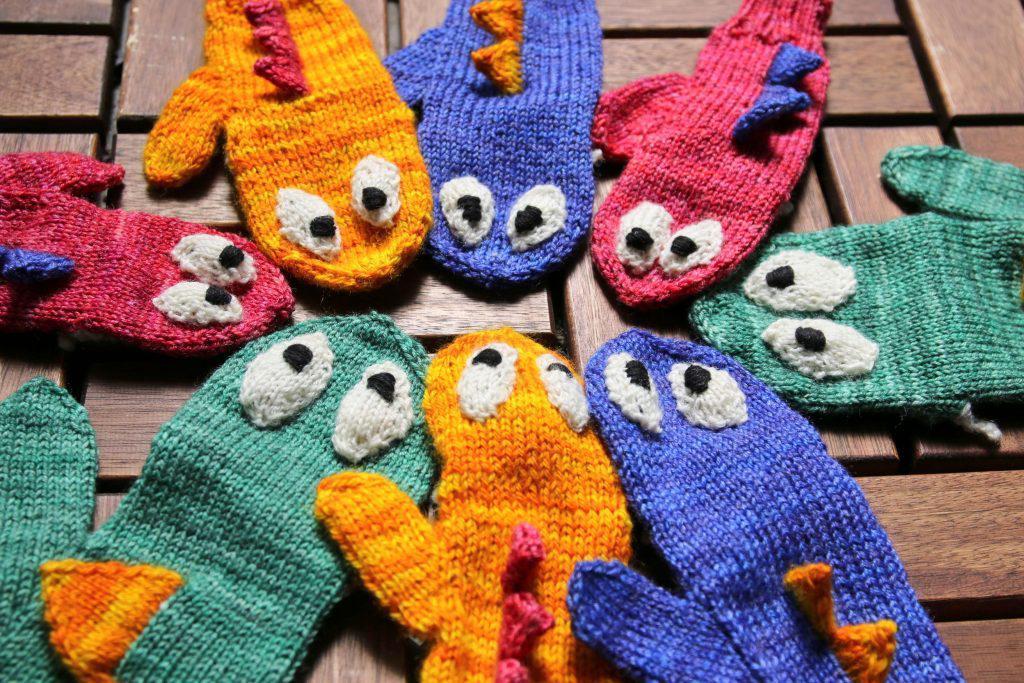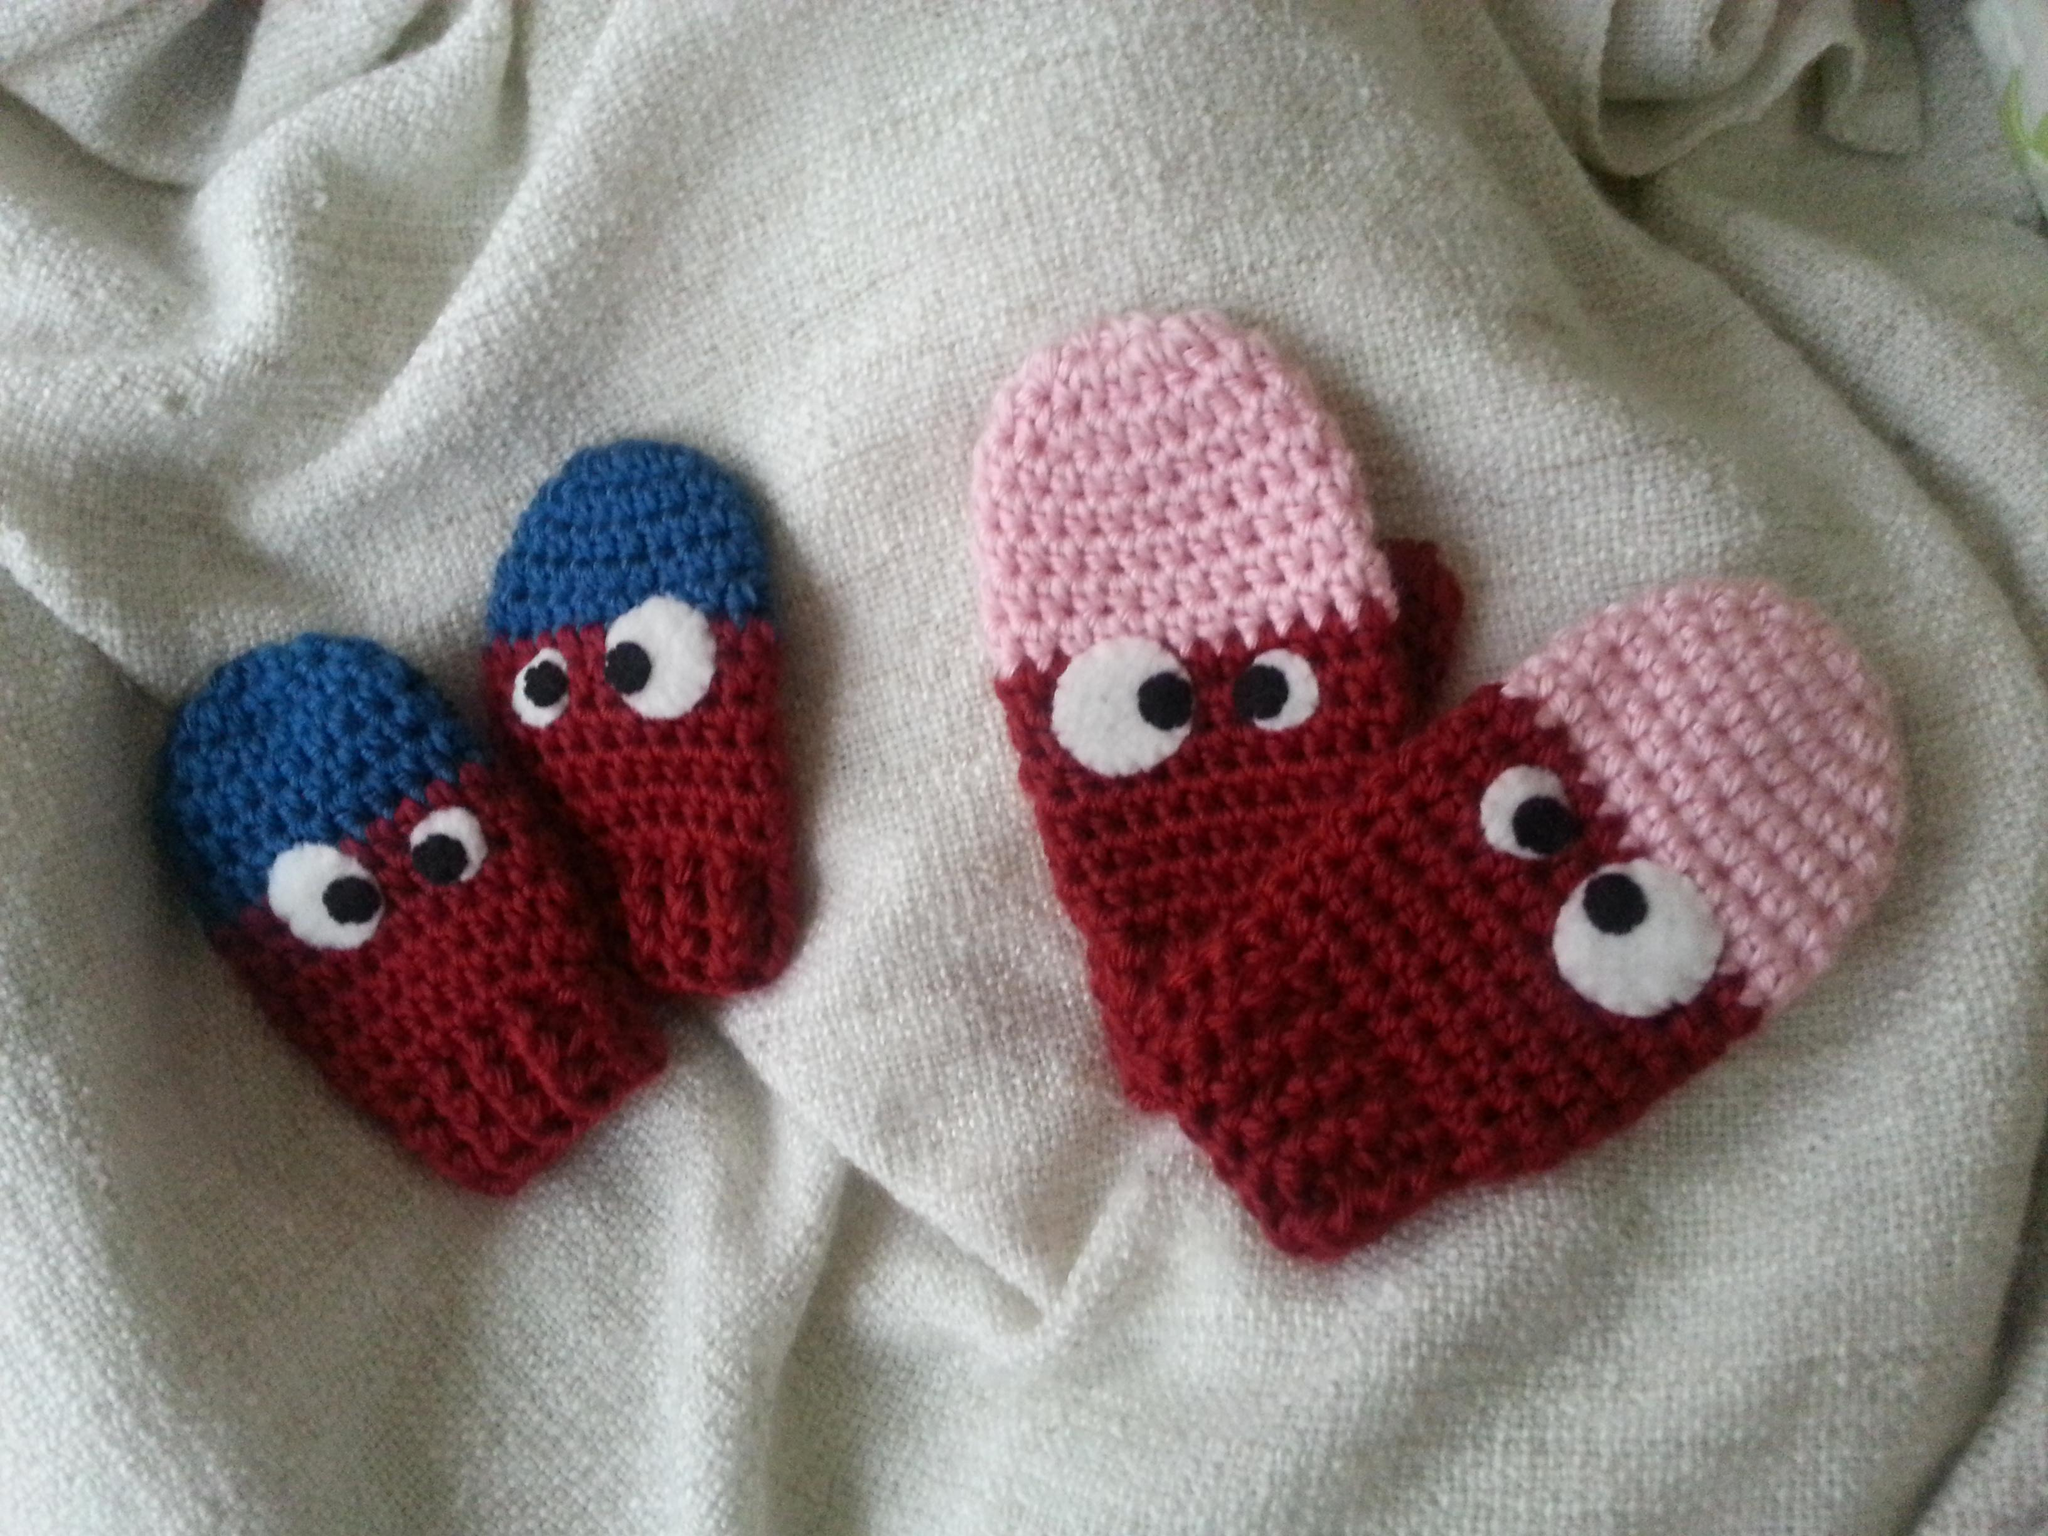The first image is the image on the left, the second image is the image on the right. Evaluate the accuracy of this statement regarding the images: "There are no more than two pairs of gloves with eyeballs.". Is it true? Answer yes or no. No. The first image is the image on the left, the second image is the image on the right. Examine the images to the left and right. Is the description "An image shows one pair of blue mittens with cartoon-like eyes, and no other mittens." accurate? Answer yes or no. No. 